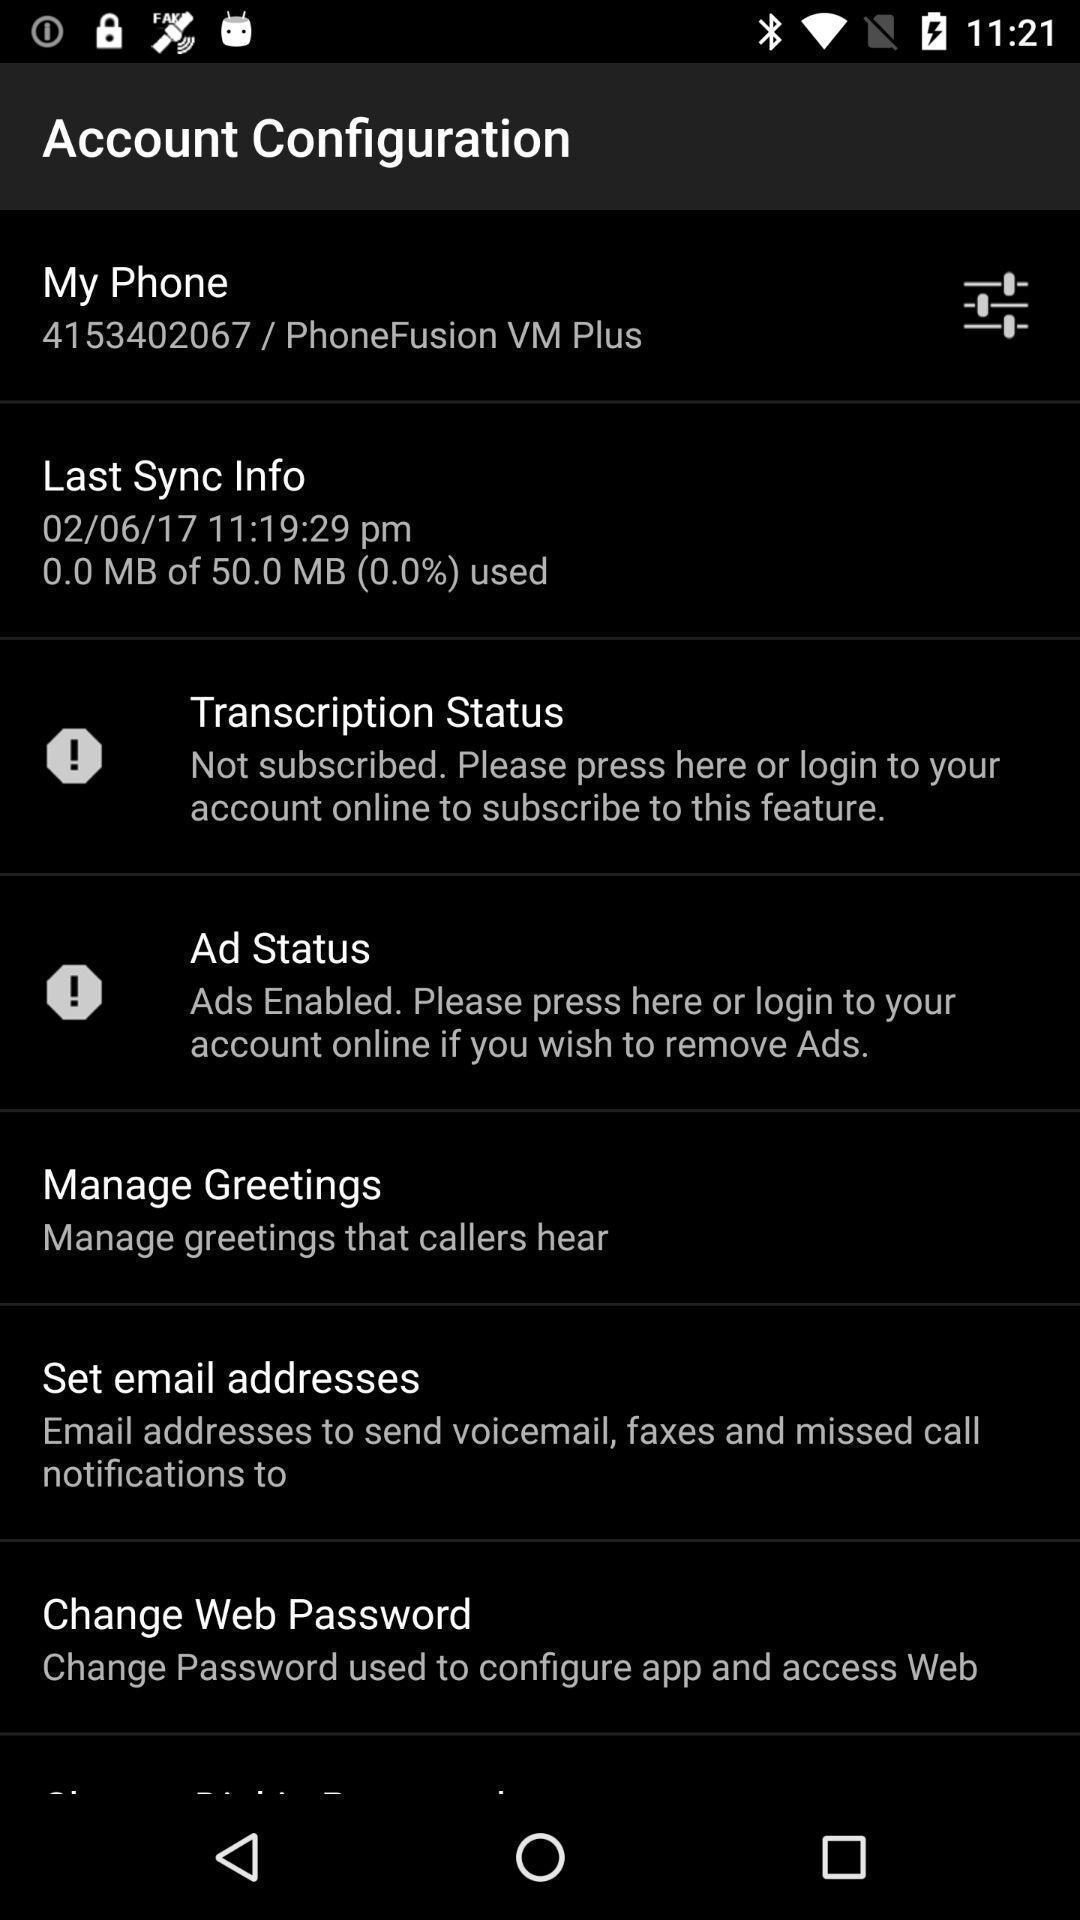Provide a detailed account of this screenshot. Page displaying settings for configuration of account. 